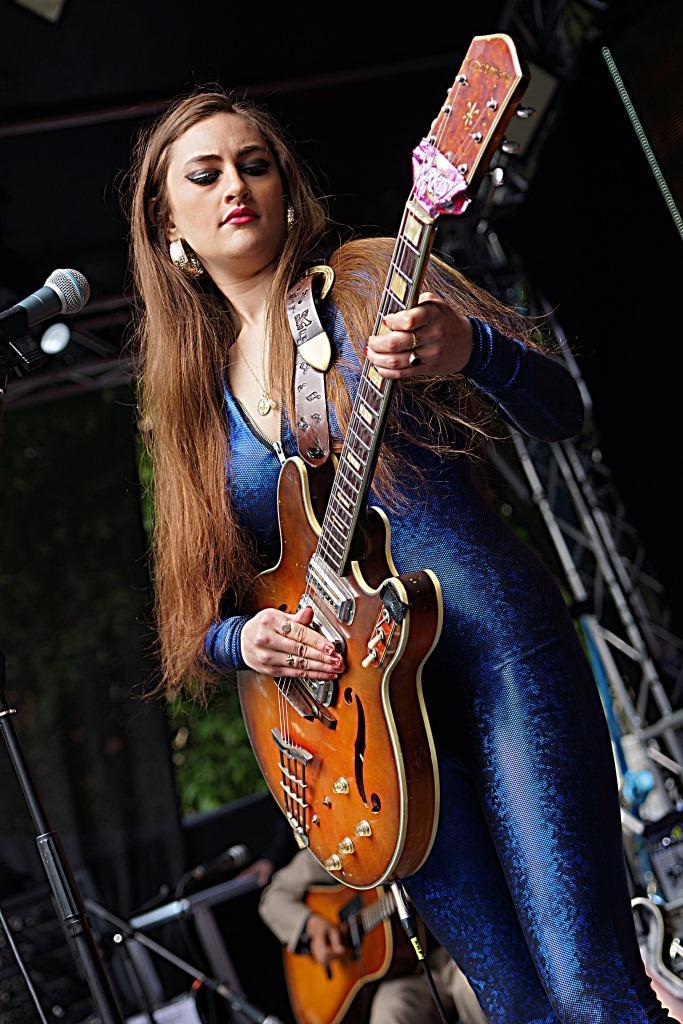How would you summarize this image in a sentence or two? In this image, we an see few peoples are playing a guitar in-front of microphones. At the bottom, we can see wire, stand and some instruments here. There is a background we can see rods and roof. 